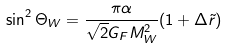Convert formula to latex. <formula><loc_0><loc_0><loc_500><loc_500>\sin ^ { 2 } { \Theta _ { W } } = \frac { \pi \alpha } { \sqrt { 2 } G _ { F } M _ { W } ^ { 2 } } ( 1 + \Delta \tilde { r } )</formula> 